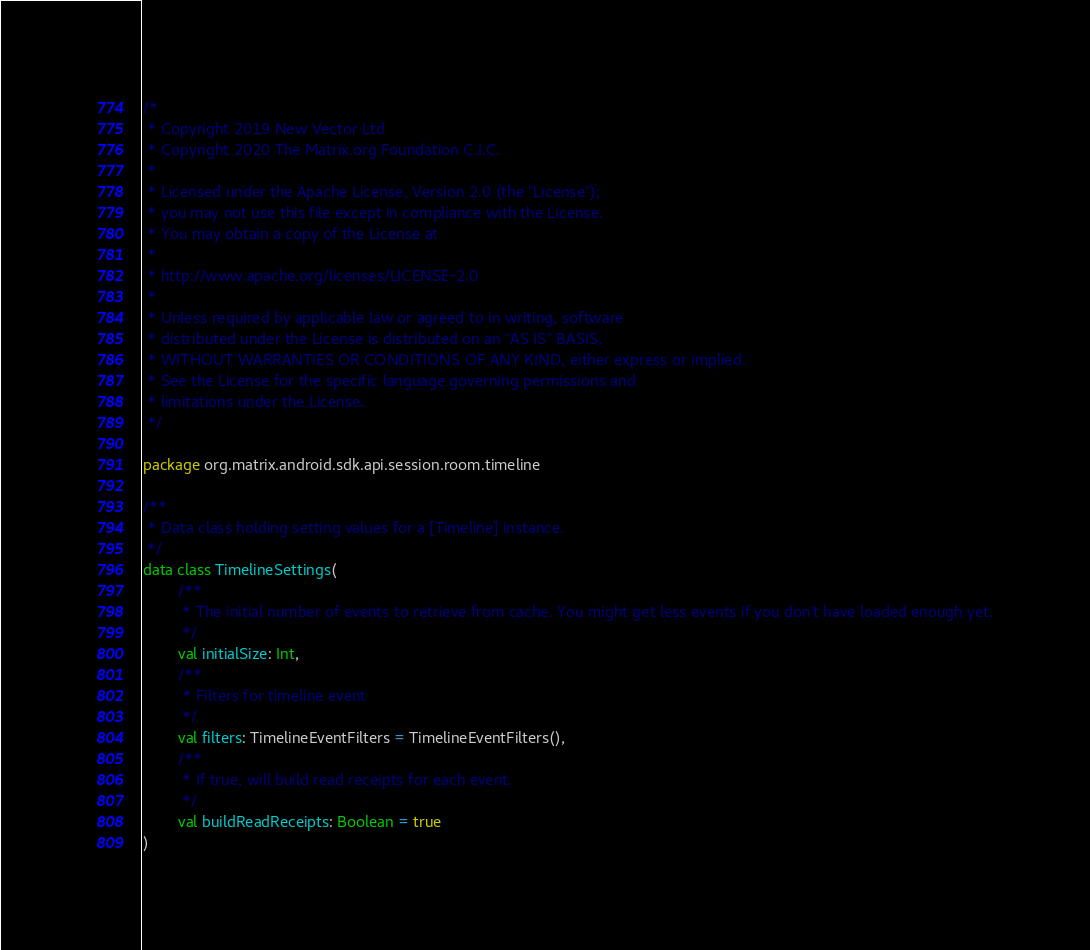<code> <loc_0><loc_0><loc_500><loc_500><_Kotlin_>/*
 * Copyright 2019 New Vector Ltd
 * Copyright 2020 The Matrix.org Foundation C.I.C.
 *
 * Licensed under the Apache License, Version 2.0 (the "License");
 * you may not use this file except in compliance with the License.
 * You may obtain a copy of the License at
 *
 * http://www.apache.org/licenses/LICENSE-2.0
 *
 * Unless required by applicable law or agreed to in writing, software
 * distributed under the License is distributed on an "AS IS" BASIS,
 * WITHOUT WARRANTIES OR CONDITIONS OF ANY KIND, either express or implied.
 * See the License for the specific language governing permissions and
 * limitations under the License.
 */

package org.matrix.android.sdk.api.session.room.timeline

/**
 * Data class holding setting values for a [Timeline] instance.
 */
data class TimelineSettings(
        /**
         * The initial number of events to retrieve from cache. You might get less events if you don't have loaded enough yet.
         */
        val initialSize: Int,
        /**
         * Filters for timeline event
         */
        val filters: TimelineEventFilters = TimelineEventFilters(),
        /**
         * If true, will build read receipts for each event.
         */
        val buildReadReceipts: Boolean = true
)
</code> 